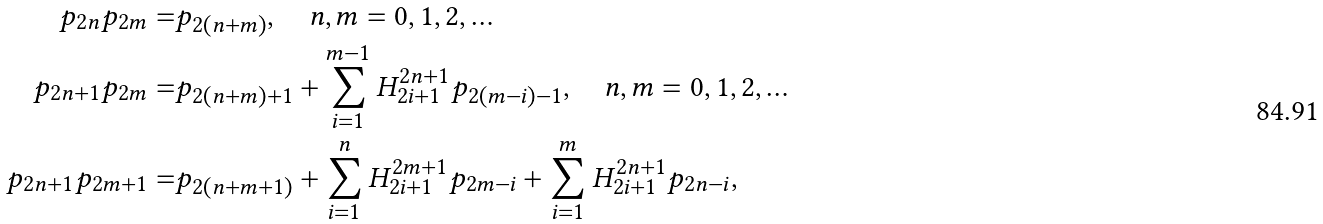<formula> <loc_0><loc_0><loc_500><loc_500>p _ { 2 n } p _ { 2 m } = & p _ { 2 ( n + m ) } , \quad n , m = 0 , 1 , 2 , \dots \\ p _ { 2 n + 1 } p _ { 2 m } = & p _ { 2 ( n + m ) + 1 } + \sum _ { i = 1 } ^ { m - 1 } H ^ { 2 n + 1 } _ { 2 i + 1 } p _ { 2 ( m - i ) - 1 } , \quad n , m = 0 , 1 , 2 , \dots \\ p _ { 2 n + 1 } p _ { 2 m + 1 } = & p _ { 2 ( n + m + 1 ) } + \sum _ { i = 1 } ^ { n } H ^ { 2 m + 1 } _ { 2 i + 1 } p _ { 2 { m - i } } + \sum _ { i = 1 } ^ { m } H ^ { 2 n + 1 } _ { 2 i + 1 } p _ { 2 { n - i } } ,</formula> 